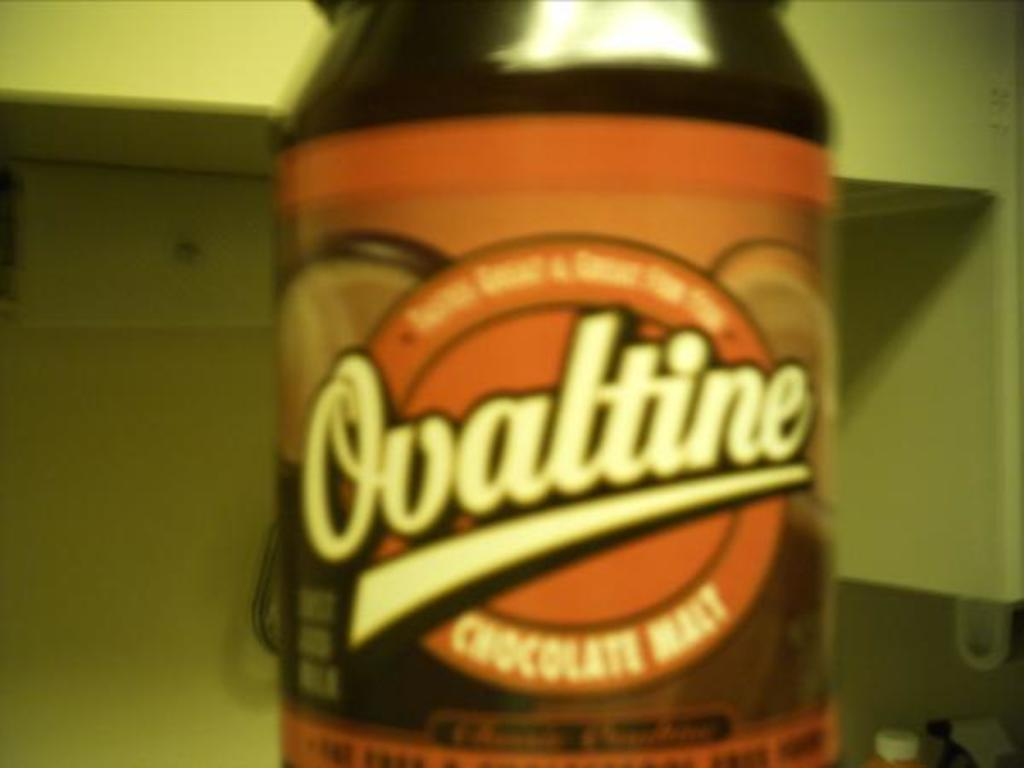<image>
Write a terse but informative summary of the picture. Ovaltine bottle sits alone with a white background 